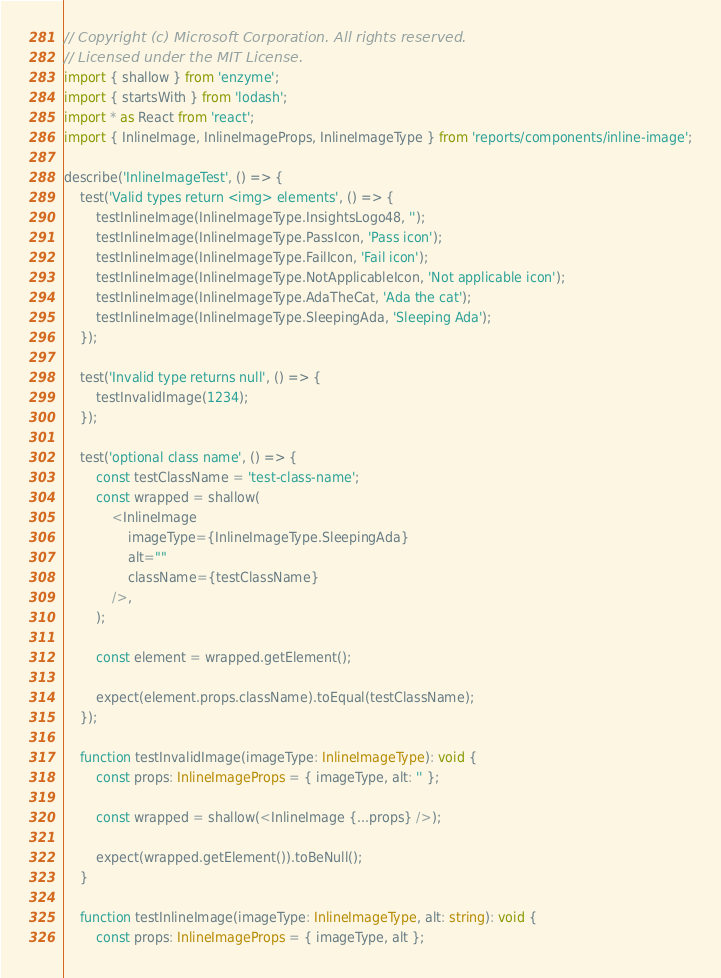Convert code to text. <code><loc_0><loc_0><loc_500><loc_500><_TypeScript_>// Copyright (c) Microsoft Corporation. All rights reserved.
// Licensed under the MIT License.
import { shallow } from 'enzyme';
import { startsWith } from 'lodash';
import * as React from 'react';
import { InlineImage, InlineImageProps, InlineImageType } from 'reports/components/inline-image';

describe('InlineImageTest', () => {
    test('Valid types return <img> elements', () => {
        testInlineImage(InlineImageType.InsightsLogo48, '');
        testInlineImage(InlineImageType.PassIcon, 'Pass icon');
        testInlineImage(InlineImageType.FailIcon, 'Fail icon');
        testInlineImage(InlineImageType.NotApplicableIcon, 'Not applicable icon');
        testInlineImage(InlineImageType.AdaTheCat, 'Ada the cat');
        testInlineImage(InlineImageType.SleepingAda, 'Sleeping Ada');
    });

    test('Invalid type returns null', () => {
        testInvalidImage(1234);
    });

    test('optional class name', () => {
        const testClassName = 'test-class-name';
        const wrapped = shallow(
            <InlineImage
                imageType={InlineImageType.SleepingAda}
                alt=""
                className={testClassName}
            />,
        );

        const element = wrapped.getElement();

        expect(element.props.className).toEqual(testClassName);
    });

    function testInvalidImage(imageType: InlineImageType): void {
        const props: InlineImageProps = { imageType, alt: '' };

        const wrapped = shallow(<InlineImage {...props} />);

        expect(wrapped.getElement()).toBeNull();
    }

    function testInlineImage(imageType: InlineImageType, alt: string): void {
        const props: InlineImageProps = { imageType, alt };
</code> 